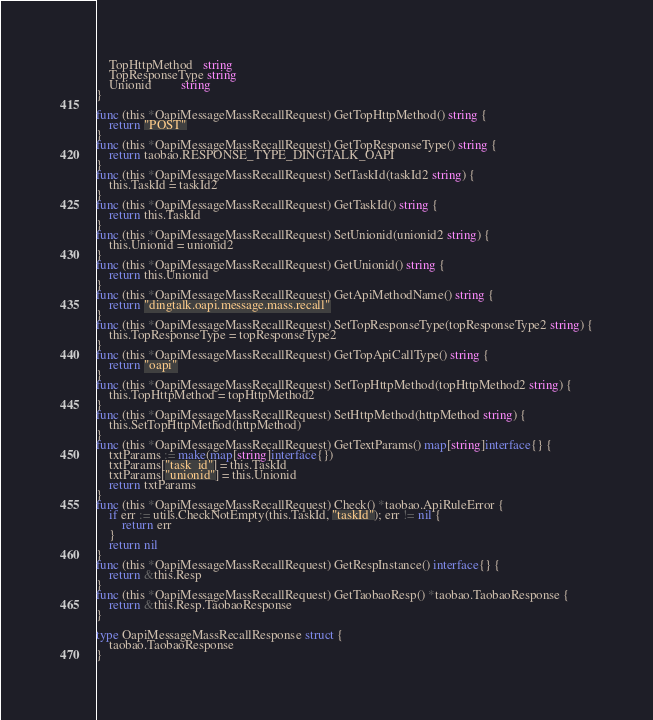Convert code to text. <code><loc_0><loc_0><loc_500><loc_500><_Go_>	TopHttpMethod   string
	TopResponseType string
	Unionid         string
}

func (this *OapiMessageMassRecallRequest) GetTopHttpMethod() string {
	return "POST"
}
func (this *OapiMessageMassRecallRequest) GetTopResponseType() string {
	return taobao.RESPONSE_TYPE_DINGTALK_OAPI
}
func (this *OapiMessageMassRecallRequest) SetTaskId(taskId2 string) {
	this.TaskId = taskId2
}
func (this *OapiMessageMassRecallRequest) GetTaskId() string {
	return this.TaskId
}
func (this *OapiMessageMassRecallRequest) SetUnionid(unionid2 string) {
	this.Unionid = unionid2
}
func (this *OapiMessageMassRecallRequest) GetUnionid() string {
	return this.Unionid
}
func (this *OapiMessageMassRecallRequest) GetApiMethodName() string {
	return "dingtalk.oapi.message.mass.recall"
}
func (this *OapiMessageMassRecallRequest) SetTopResponseType(topResponseType2 string) {
	this.TopResponseType = topResponseType2
}
func (this *OapiMessageMassRecallRequest) GetTopApiCallType() string {
	return "oapi"
}
func (this *OapiMessageMassRecallRequest) SetTopHttpMethod(topHttpMethod2 string) {
	this.TopHttpMethod = topHttpMethod2
}
func (this *OapiMessageMassRecallRequest) SetHttpMethod(httpMethod string) {
	this.SetTopHttpMethod(httpMethod)
}
func (this *OapiMessageMassRecallRequest) GetTextParams() map[string]interface{} {
	txtParams := make(map[string]interface{})
	txtParams["task_id"] = this.TaskId
	txtParams["unionid"] = this.Unionid
	return txtParams
}
func (this *OapiMessageMassRecallRequest) Check() *taobao.ApiRuleError {
	if err := utils.CheckNotEmpty(this.TaskId, "taskId"); err != nil {
		return err
	}
	return nil
}
func (this *OapiMessageMassRecallRequest) GetRespInstance() interface{} {
	return &this.Resp
}
func (this *OapiMessageMassRecallRequest) GetTaobaoResp() *taobao.TaobaoResponse {
	return &this.Resp.TaobaoResponse
}

type OapiMessageMassRecallResponse struct {
	taobao.TaobaoResponse
}
</code> 